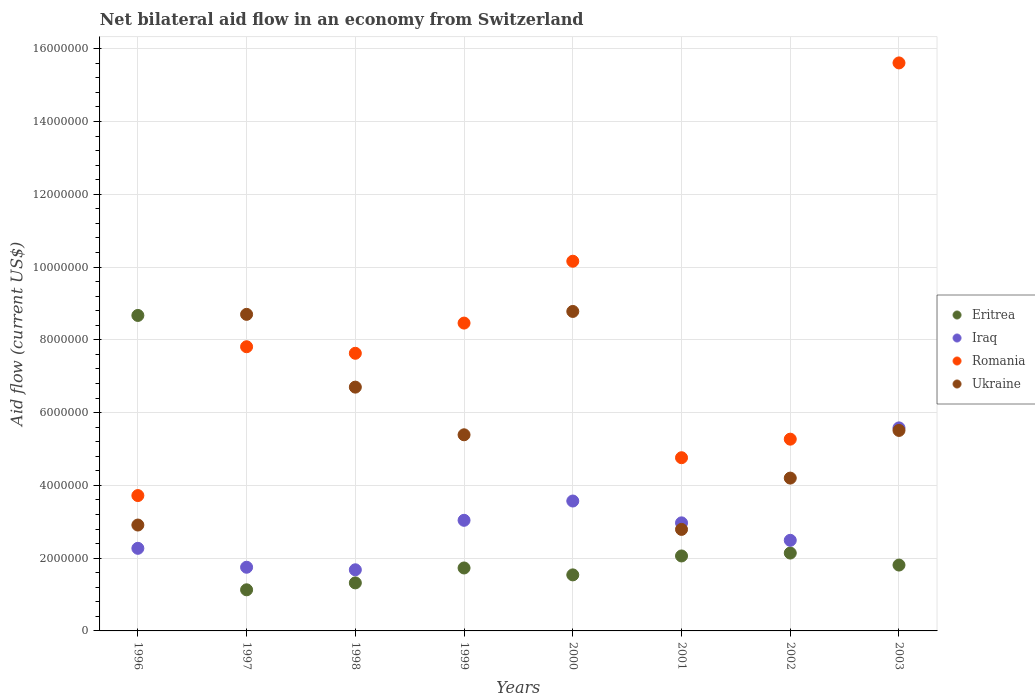How many different coloured dotlines are there?
Keep it short and to the point. 4. Is the number of dotlines equal to the number of legend labels?
Make the answer very short. Yes. What is the net bilateral aid flow in Ukraine in 1997?
Your answer should be very brief. 8.70e+06. Across all years, what is the maximum net bilateral aid flow in Eritrea?
Your answer should be very brief. 8.67e+06. Across all years, what is the minimum net bilateral aid flow in Ukraine?
Provide a succinct answer. 2.79e+06. In which year was the net bilateral aid flow in Ukraine maximum?
Make the answer very short. 2000. What is the total net bilateral aid flow in Romania in the graph?
Your answer should be compact. 6.34e+07. What is the difference between the net bilateral aid flow in Iraq in 1997 and that in 2003?
Your answer should be compact. -3.83e+06. What is the difference between the net bilateral aid flow in Romania in 2000 and the net bilateral aid flow in Ukraine in 1996?
Offer a very short reply. 7.25e+06. What is the average net bilateral aid flow in Iraq per year?
Make the answer very short. 2.92e+06. In the year 1998, what is the difference between the net bilateral aid flow in Ukraine and net bilateral aid flow in Romania?
Keep it short and to the point. -9.30e+05. In how many years, is the net bilateral aid flow in Iraq greater than 11600000 US$?
Ensure brevity in your answer.  0. What is the ratio of the net bilateral aid flow in Eritrea in 1996 to that in 2001?
Provide a short and direct response. 4.21. What is the difference between the highest and the second highest net bilateral aid flow in Ukraine?
Keep it short and to the point. 8.00e+04. What is the difference between the highest and the lowest net bilateral aid flow in Romania?
Your answer should be very brief. 1.19e+07. Is the sum of the net bilateral aid flow in Eritrea in 1997 and 2001 greater than the maximum net bilateral aid flow in Ukraine across all years?
Keep it short and to the point. No. Is it the case that in every year, the sum of the net bilateral aid flow in Iraq and net bilateral aid flow in Romania  is greater than the sum of net bilateral aid flow in Ukraine and net bilateral aid flow in Eritrea?
Offer a very short reply. No. Is it the case that in every year, the sum of the net bilateral aid flow in Iraq and net bilateral aid flow in Ukraine  is greater than the net bilateral aid flow in Romania?
Give a very brief answer. No. Is the net bilateral aid flow in Eritrea strictly greater than the net bilateral aid flow in Iraq over the years?
Provide a succinct answer. No. How many dotlines are there?
Offer a terse response. 4. Are the values on the major ticks of Y-axis written in scientific E-notation?
Ensure brevity in your answer.  No. Does the graph contain any zero values?
Offer a terse response. No. Where does the legend appear in the graph?
Your answer should be compact. Center right. How are the legend labels stacked?
Offer a terse response. Vertical. What is the title of the graph?
Your answer should be very brief. Net bilateral aid flow in an economy from Switzerland. What is the label or title of the Y-axis?
Your answer should be very brief. Aid flow (current US$). What is the Aid flow (current US$) in Eritrea in 1996?
Your answer should be very brief. 8.67e+06. What is the Aid flow (current US$) in Iraq in 1996?
Provide a short and direct response. 2.27e+06. What is the Aid flow (current US$) in Romania in 1996?
Your answer should be very brief. 3.72e+06. What is the Aid flow (current US$) of Ukraine in 1996?
Keep it short and to the point. 2.91e+06. What is the Aid flow (current US$) of Eritrea in 1997?
Offer a very short reply. 1.13e+06. What is the Aid flow (current US$) in Iraq in 1997?
Your answer should be compact. 1.75e+06. What is the Aid flow (current US$) of Romania in 1997?
Provide a short and direct response. 7.81e+06. What is the Aid flow (current US$) in Ukraine in 1997?
Provide a succinct answer. 8.70e+06. What is the Aid flow (current US$) in Eritrea in 1998?
Provide a short and direct response. 1.32e+06. What is the Aid flow (current US$) in Iraq in 1998?
Your answer should be very brief. 1.68e+06. What is the Aid flow (current US$) in Romania in 1998?
Your answer should be compact. 7.63e+06. What is the Aid flow (current US$) in Ukraine in 1998?
Offer a terse response. 6.70e+06. What is the Aid flow (current US$) in Eritrea in 1999?
Your response must be concise. 1.73e+06. What is the Aid flow (current US$) of Iraq in 1999?
Make the answer very short. 3.04e+06. What is the Aid flow (current US$) of Romania in 1999?
Your answer should be very brief. 8.46e+06. What is the Aid flow (current US$) in Ukraine in 1999?
Keep it short and to the point. 5.39e+06. What is the Aid flow (current US$) in Eritrea in 2000?
Make the answer very short. 1.54e+06. What is the Aid flow (current US$) of Iraq in 2000?
Your answer should be very brief. 3.57e+06. What is the Aid flow (current US$) of Romania in 2000?
Offer a terse response. 1.02e+07. What is the Aid flow (current US$) in Ukraine in 2000?
Ensure brevity in your answer.  8.78e+06. What is the Aid flow (current US$) of Eritrea in 2001?
Ensure brevity in your answer.  2.06e+06. What is the Aid flow (current US$) in Iraq in 2001?
Ensure brevity in your answer.  2.97e+06. What is the Aid flow (current US$) in Romania in 2001?
Provide a short and direct response. 4.76e+06. What is the Aid flow (current US$) of Ukraine in 2001?
Offer a terse response. 2.79e+06. What is the Aid flow (current US$) of Eritrea in 2002?
Ensure brevity in your answer.  2.14e+06. What is the Aid flow (current US$) in Iraq in 2002?
Ensure brevity in your answer.  2.49e+06. What is the Aid flow (current US$) of Romania in 2002?
Keep it short and to the point. 5.27e+06. What is the Aid flow (current US$) in Ukraine in 2002?
Keep it short and to the point. 4.20e+06. What is the Aid flow (current US$) of Eritrea in 2003?
Offer a very short reply. 1.81e+06. What is the Aid flow (current US$) in Iraq in 2003?
Provide a short and direct response. 5.58e+06. What is the Aid flow (current US$) in Romania in 2003?
Give a very brief answer. 1.56e+07. What is the Aid flow (current US$) in Ukraine in 2003?
Your answer should be compact. 5.51e+06. Across all years, what is the maximum Aid flow (current US$) in Eritrea?
Your answer should be very brief. 8.67e+06. Across all years, what is the maximum Aid flow (current US$) in Iraq?
Your answer should be compact. 5.58e+06. Across all years, what is the maximum Aid flow (current US$) in Romania?
Provide a short and direct response. 1.56e+07. Across all years, what is the maximum Aid flow (current US$) in Ukraine?
Ensure brevity in your answer.  8.78e+06. Across all years, what is the minimum Aid flow (current US$) of Eritrea?
Provide a succinct answer. 1.13e+06. Across all years, what is the minimum Aid flow (current US$) of Iraq?
Your answer should be compact. 1.68e+06. Across all years, what is the minimum Aid flow (current US$) of Romania?
Provide a short and direct response. 3.72e+06. Across all years, what is the minimum Aid flow (current US$) of Ukraine?
Make the answer very short. 2.79e+06. What is the total Aid flow (current US$) of Eritrea in the graph?
Give a very brief answer. 2.04e+07. What is the total Aid flow (current US$) of Iraq in the graph?
Your answer should be very brief. 2.34e+07. What is the total Aid flow (current US$) in Romania in the graph?
Your response must be concise. 6.34e+07. What is the total Aid flow (current US$) in Ukraine in the graph?
Give a very brief answer. 4.50e+07. What is the difference between the Aid flow (current US$) of Eritrea in 1996 and that in 1997?
Your answer should be very brief. 7.54e+06. What is the difference between the Aid flow (current US$) in Iraq in 1996 and that in 1997?
Your answer should be compact. 5.20e+05. What is the difference between the Aid flow (current US$) of Romania in 1996 and that in 1997?
Provide a succinct answer. -4.09e+06. What is the difference between the Aid flow (current US$) in Ukraine in 1996 and that in 1997?
Ensure brevity in your answer.  -5.79e+06. What is the difference between the Aid flow (current US$) of Eritrea in 1996 and that in 1998?
Provide a short and direct response. 7.35e+06. What is the difference between the Aid flow (current US$) of Iraq in 1996 and that in 1998?
Ensure brevity in your answer.  5.90e+05. What is the difference between the Aid flow (current US$) of Romania in 1996 and that in 1998?
Make the answer very short. -3.91e+06. What is the difference between the Aid flow (current US$) of Ukraine in 1996 and that in 1998?
Provide a short and direct response. -3.79e+06. What is the difference between the Aid flow (current US$) in Eritrea in 1996 and that in 1999?
Make the answer very short. 6.94e+06. What is the difference between the Aid flow (current US$) of Iraq in 1996 and that in 1999?
Your response must be concise. -7.70e+05. What is the difference between the Aid flow (current US$) of Romania in 1996 and that in 1999?
Your answer should be very brief. -4.74e+06. What is the difference between the Aid flow (current US$) in Ukraine in 1996 and that in 1999?
Offer a terse response. -2.48e+06. What is the difference between the Aid flow (current US$) of Eritrea in 1996 and that in 2000?
Your answer should be very brief. 7.13e+06. What is the difference between the Aid flow (current US$) in Iraq in 1996 and that in 2000?
Keep it short and to the point. -1.30e+06. What is the difference between the Aid flow (current US$) of Romania in 1996 and that in 2000?
Offer a very short reply. -6.44e+06. What is the difference between the Aid flow (current US$) of Ukraine in 1996 and that in 2000?
Offer a terse response. -5.87e+06. What is the difference between the Aid flow (current US$) of Eritrea in 1996 and that in 2001?
Your answer should be very brief. 6.61e+06. What is the difference between the Aid flow (current US$) in Iraq in 1996 and that in 2001?
Make the answer very short. -7.00e+05. What is the difference between the Aid flow (current US$) in Romania in 1996 and that in 2001?
Your response must be concise. -1.04e+06. What is the difference between the Aid flow (current US$) of Ukraine in 1996 and that in 2001?
Offer a very short reply. 1.20e+05. What is the difference between the Aid flow (current US$) of Eritrea in 1996 and that in 2002?
Make the answer very short. 6.53e+06. What is the difference between the Aid flow (current US$) in Iraq in 1996 and that in 2002?
Your response must be concise. -2.20e+05. What is the difference between the Aid flow (current US$) in Romania in 1996 and that in 2002?
Provide a short and direct response. -1.55e+06. What is the difference between the Aid flow (current US$) in Ukraine in 1996 and that in 2002?
Keep it short and to the point. -1.29e+06. What is the difference between the Aid flow (current US$) of Eritrea in 1996 and that in 2003?
Offer a terse response. 6.86e+06. What is the difference between the Aid flow (current US$) of Iraq in 1996 and that in 2003?
Provide a short and direct response. -3.31e+06. What is the difference between the Aid flow (current US$) of Romania in 1996 and that in 2003?
Your answer should be very brief. -1.19e+07. What is the difference between the Aid flow (current US$) in Ukraine in 1996 and that in 2003?
Give a very brief answer. -2.60e+06. What is the difference between the Aid flow (current US$) of Iraq in 1997 and that in 1998?
Your answer should be very brief. 7.00e+04. What is the difference between the Aid flow (current US$) of Eritrea in 1997 and that in 1999?
Ensure brevity in your answer.  -6.00e+05. What is the difference between the Aid flow (current US$) of Iraq in 1997 and that in 1999?
Offer a terse response. -1.29e+06. What is the difference between the Aid flow (current US$) of Romania in 1997 and that in 1999?
Provide a short and direct response. -6.50e+05. What is the difference between the Aid flow (current US$) in Ukraine in 1997 and that in 1999?
Keep it short and to the point. 3.31e+06. What is the difference between the Aid flow (current US$) in Eritrea in 1997 and that in 2000?
Ensure brevity in your answer.  -4.10e+05. What is the difference between the Aid flow (current US$) of Iraq in 1997 and that in 2000?
Offer a very short reply. -1.82e+06. What is the difference between the Aid flow (current US$) of Romania in 1997 and that in 2000?
Ensure brevity in your answer.  -2.35e+06. What is the difference between the Aid flow (current US$) in Ukraine in 1997 and that in 2000?
Make the answer very short. -8.00e+04. What is the difference between the Aid flow (current US$) in Eritrea in 1997 and that in 2001?
Keep it short and to the point. -9.30e+05. What is the difference between the Aid flow (current US$) in Iraq in 1997 and that in 2001?
Ensure brevity in your answer.  -1.22e+06. What is the difference between the Aid flow (current US$) in Romania in 1997 and that in 2001?
Ensure brevity in your answer.  3.05e+06. What is the difference between the Aid flow (current US$) of Ukraine in 1997 and that in 2001?
Offer a terse response. 5.91e+06. What is the difference between the Aid flow (current US$) of Eritrea in 1997 and that in 2002?
Provide a succinct answer. -1.01e+06. What is the difference between the Aid flow (current US$) of Iraq in 1997 and that in 2002?
Give a very brief answer. -7.40e+05. What is the difference between the Aid flow (current US$) of Romania in 1997 and that in 2002?
Keep it short and to the point. 2.54e+06. What is the difference between the Aid flow (current US$) of Ukraine in 1997 and that in 2002?
Ensure brevity in your answer.  4.50e+06. What is the difference between the Aid flow (current US$) of Eritrea in 1997 and that in 2003?
Your answer should be very brief. -6.80e+05. What is the difference between the Aid flow (current US$) in Iraq in 1997 and that in 2003?
Offer a terse response. -3.83e+06. What is the difference between the Aid flow (current US$) in Romania in 1997 and that in 2003?
Make the answer very short. -7.80e+06. What is the difference between the Aid flow (current US$) of Ukraine in 1997 and that in 2003?
Make the answer very short. 3.19e+06. What is the difference between the Aid flow (current US$) of Eritrea in 1998 and that in 1999?
Provide a short and direct response. -4.10e+05. What is the difference between the Aid flow (current US$) in Iraq in 1998 and that in 1999?
Keep it short and to the point. -1.36e+06. What is the difference between the Aid flow (current US$) of Romania in 1998 and that in 1999?
Make the answer very short. -8.30e+05. What is the difference between the Aid flow (current US$) of Ukraine in 1998 and that in 1999?
Offer a very short reply. 1.31e+06. What is the difference between the Aid flow (current US$) of Iraq in 1998 and that in 2000?
Your response must be concise. -1.89e+06. What is the difference between the Aid flow (current US$) of Romania in 1998 and that in 2000?
Keep it short and to the point. -2.53e+06. What is the difference between the Aid flow (current US$) in Ukraine in 1998 and that in 2000?
Offer a very short reply. -2.08e+06. What is the difference between the Aid flow (current US$) in Eritrea in 1998 and that in 2001?
Ensure brevity in your answer.  -7.40e+05. What is the difference between the Aid flow (current US$) of Iraq in 1998 and that in 2001?
Keep it short and to the point. -1.29e+06. What is the difference between the Aid flow (current US$) in Romania in 1998 and that in 2001?
Your answer should be compact. 2.87e+06. What is the difference between the Aid flow (current US$) of Ukraine in 1998 and that in 2001?
Provide a succinct answer. 3.91e+06. What is the difference between the Aid flow (current US$) in Eritrea in 1998 and that in 2002?
Offer a very short reply. -8.20e+05. What is the difference between the Aid flow (current US$) in Iraq in 1998 and that in 2002?
Your answer should be compact. -8.10e+05. What is the difference between the Aid flow (current US$) of Romania in 1998 and that in 2002?
Ensure brevity in your answer.  2.36e+06. What is the difference between the Aid flow (current US$) in Ukraine in 1998 and that in 2002?
Your response must be concise. 2.50e+06. What is the difference between the Aid flow (current US$) in Eritrea in 1998 and that in 2003?
Provide a succinct answer. -4.90e+05. What is the difference between the Aid flow (current US$) of Iraq in 1998 and that in 2003?
Your answer should be very brief. -3.90e+06. What is the difference between the Aid flow (current US$) in Romania in 1998 and that in 2003?
Ensure brevity in your answer.  -7.98e+06. What is the difference between the Aid flow (current US$) in Ukraine in 1998 and that in 2003?
Keep it short and to the point. 1.19e+06. What is the difference between the Aid flow (current US$) in Eritrea in 1999 and that in 2000?
Give a very brief answer. 1.90e+05. What is the difference between the Aid flow (current US$) in Iraq in 1999 and that in 2000?
Your response must be concise. -5.30e+05. What is the difference between the Aid flow (current US$) in Romania in 1999 and that in 2000?
Make the answer very short. -1.70e+06. What is the difference between the Aid flow (current US$) of Ukraine in 1999 and that in 2000?
Make the answer very short. -3.39e+06. What is the difference between the Aid flow (current US$) in Eritrea in 1999 and that in 2001?
Your answer should be very brief. -3.30e+05. What is the difference between the Aid flow (current US$) in Romania in 1999 and that in 2001?
Your answer should be compact. 3.70e+06. What is the difference between the Aid flow (current US$) of Ukraine in 1999 and that in 2001?
Provide a short and direct response. 2.60e+06. What is the difference between the Aid flow (current US$) in Eritrea in 1999 and that in 2002?
Offer a very short reply. -4.10e+05. What is the difference between the Aid flow (current US$) in Iraq in 1999 and that in 2002?
Offer a terse response. 5.50e+05. What is the difference between the Aid flow (current US$) of Romania in 1999 and that in 2002?
Offer a very short reply. 3.19e+06. What is the difference between the Aid flow (current US$) in Ukraine in 1999 and that in 2002?
Keep it short and to the point. 1.19e+06. What is the difference between the Aid flow (current US$) in Iraq in 1999 and that in 2003?
Offer a terse response. -2.54e+06. What is the difference between the Aid flow (current US$) of Romania in 1999 and that in 2003?
Provide a succinct answer. -7.15e+06. What is the difference between the Aid flow (current US$) in Eritrea in 2000 and that in 2001?
Provide a succinct answer. -5.20e+05. What is the difference between the Aid flow (current US$) of Romania in 2000 and that in 2001?
Offer a very short reply. 5.40e+06. What is the difference between the Aid flow (current US$) of Ukraine in 2000 and that in 2001?
Give a very brief answer. 5.99e+06. What is the difference between the Aid flow (current US$) of Eritrea in 2000 and that in 2002?
Provide a short and direct response. -6.00e+05. What is the difference between the Aid flow (current US$) in Iraq in 2000 and that in 2002?
Your answer should be compact. 1.08e+06. What is the difference between the Aid flow (current US$) in Romania in 2000 and that in 2002?
Keep it short and to the point. 4.89e+06. What is the difference between the Aid flow (current US$) of Ukraine in 2000 and that in 2002?
Ensure brevity in your answer.  4.58e+06. What is the difference between the Aid flow (current US$) in Iraq in 2000 and that in 2003?
Provide a short and direct response. -2.01e+06. What is the difference between the Aid flow (current US$) in Romania in 2000 and that in 2003?
Give a very brief answer. -5.45e+06. What is the difference between the Aid flow (current US$) in Ukraine in 2000 and that in 2003?
Offer a very short reply. 3.27e+06. What is the difference between the Aid flow (current US$) in Iraq in 2001 and that in 2002?
Your answer should be very brief. 4.80e+05. What is the difference between the Aid flow (current US$) of Romania in 2001 and that in 2002?
Offer a terse response. -5.10e+05. What is the difference between the Aid flow (current US$) of Ukraine in 2001 and that in 2002?
Offer a terse response. -1.41e+06. What is the difference between the Aid flow (current US$) in Iraq in 2001 and that in 2003?
Provide a short and direct response. -2.61e+06. What is the difference between the Aid flow (current US$) of Romania in 2001 and that in 2003?
Make the answer very short. -1.08e+07. What is the difference between the Aid flow (current US$) in Ukraine in 2001 and that in 2003?
Offer a terse response. -2.72e+06. What is the difference between the Aid flow (current US$) of Iraq in 2002 and that in 2003?
Provide a short and direct response. -3.09e+06. What is the difference between the Aid flow (current US$) in Romania in 2002 and that in 2003?
Your answer should be compact. -1.03e+07. What is the difference between the Aid flow (current US$) in Ukraine in 2002 and that in 2003?
Your answer should be compact. -1.31e+06. What is the difference between the Aid flow (current US$) in Eritrea in 1996 and the Aid flow (current US$) in Iraq in 1997?
Provide a short and direct response. 6.92e+06. What is the difference between the Aid flow (current US$) in Eritrea in 1996 and the Aid flow (current US$) in Romania in 1997?
Ensure brevity in your answer.  8.60e+05. What is the difference between the Aid flow (current US$) of Eritrea in 1996 and the Aid flow (current US$) of Ukraine in 1997?
Give a very brief answer. -3.00e+04. What is the difference between the Aid flow (current US$) in Iraq in 1996 and the Aid flow (current US$) in Romania in 1997?
Your answer should be compact. -5.54e+06. What is the difference between the Aid flow (current US$) of Iraq in 1996 and the Aid flow (current US$) of Ukraine in 1997?
Provide a short and direct response. -6.43e+06. What is the difference between the Aid flow (current US$) in Romania in 1996 and the Aid flow (current US$) in Ukraine in 1997?
Provide a short and direct response. -4.98e+06. What is the difference between the Aid flow (current US$) of Eritrea in 1996 and the Aid flow (current US$) of Iraq in 1998?
Offer a terse response. 6.99e+06. What is the difference between the Aid flow (current US$) in Eritrea in 1996 and the Aid flow (current US$) in Romania in 1998?
Your answer should be very brief. 1.04e+06. What is the difference between the Aid flow (current US$) in Eritrea in 1996 and the Aid flow (current US$) in Ukraine in 1998?
Offer a terse response. 1.97e+06. What is the difference between the Aid flow (current US$) in Iraq in 1996 and the Aid flow (current US$) in Romania in 1998?
Offer a very short reply. -5.36e+06. What is the difference between the Aid flow (current US$) in Iraq in 1996 and the Aid flow (current US$) in Ukraine in 1998?
Provide a succinct answer. -4.43e+06. What is the difference between the Aid flow (current US$) of Romania in 1996 and the Aid flow (current US$) of Ukraine in 1998?
Make the answer very short. -2.98e+06. What is the difference between the Aid flow (current US$) in Eritrea in 1996 and the Aid flow (current US$) in Iraq in 1999?
Make the answer very short. 5.63e+06. What is the difference between the Aid flow (current US$) in Eritrea in 1996 and the Aid flow (current US$) in Ukraine in 1999?
Offer a terse response. 3.28e+06. What is the difference between the Aid flow (current US$) in Iraq in 1996 and the Aid flow (current US$) in Romania in 1999?
Ensure brevity in your answer.  -6.19e+06. What is the difference between the Aid flow (current US$) in Iraq in 1996 and the Aid flow (current US$) in Ukraine in 1999?
Your answer should be compact. -3.12e+06. What is the difference between the Aid flow (current US$) of Romania in 1996 and the Aid flow (current US$) of Ukraine in 1999?
Give a very brief answer. -1.67e+06. What is the difference between the Aid flow (current US$) in Eritrea in 1996 and the Aid flow (current US$) in Iraq in 2000?
Your response must be concise. 5.10e+06. What is the difference between the Aid flow (current US$) in Eritrea in 1996 and the Aid flow (current US$) in Romania in 2000?
Your response must be concise. -1.49e+06. What is the difference between the Aid flow (current US$) of Iraq in 1996 and the Aid flow (current US$) of Romania in 2000?
Provide a succinct answer. -7.89e+06. What is the difference between the Aid flow (current US$) in Iraq in 1996 and the Aid flow (current US$) in Ukraine in 2000?
Your answer should be compact. -6.51e+06. What is the difference between the Aid flow (current US$) in Romania in 1996 and the Aid flow (current US$) in Ukraine in 2000?
Keep it short and to the point. -5.06e+06. What is the difference between the Aid flow (current US$) of Eritrea in 1996 and the Aid flow (current US$) of Iraq in 2001?
Provide a short and direct response. 5.70e+06. What is the difference between the Aid flow (current US$) of Eritrea in 1996 and the Aid flow (current US$) of Romania in 2001?
Ensure brevity in your answer.  3.91e+06. What is the difference between the Aid flow (current US$) of Eritrea in 1996 and the Aid flow (current US$) of Ukraine in 2001?
Your answer should be compact. 5.88e+06. What is the difference between the Aid flow (current US$) of Iraq in 1996 and the Aid flow (current US$) of Romania in 2001?
Ensure brevity in your answer.  -2.49e+06. What is the difference between the Aid flow (current US$) in Iraq in 1996 and the Aid flow (current US$) in Ukraine in 2001?
Your response must be concise. -5.20e+05. What is the difference between the Aid flow (current US$) in Romania in 1996 and the Aid flow (current US$) in Ukraine in 2001?
Provide a short and direct response. 9.30e+05. What is the difference between the Aid flow (current US$) of Eritrea in 1996 and the Aid flow (current US$) of Iraq in 2002?
Provide a succinct answer. 6.18e+06. What is the difference between the Aid flow (current US$) of Eritrea in 1996 and the Aid flow (current US$) of Romania in 2002?
Your answer should be compact. 3.40e+06. What is the difference between the Aid flow (current US$) of Eritrea in 1996 and the Aid flow (current US$) of Ukraine in 2002?
Provide a succinct answer. 4.47e+06. What is the difference between the Aid flow (current US$) of Iraq in 1996 and the Aid flow (current US$) of Romania in 2002?
Keep it short and to the point. -3.00e+06. What is the difference between the Aid flow (current US$) of Iraq in 1996 and the Aid flow (current US$) of Ukraine in 2002?
Provide a short and direct response. -1.93e+06. What is the difference between the Aid flow (current US$) of Romania in 1996 and the Aid flow (current US$) of Ukraine in 2002?
Make the answer very short. -4.80e+05. What is the difference between the Aid flow (current US$) of Eritrea in 1996 and the Aid flow (current US$) of Iraq in 2003?
Your answer should be very brief. 3.09e+06. What is the difference between the Aid flow (current US$) in Eritrea in 1996 and the Aid flow (current US$) in Romania in 2003?
Give a very brief answer. -6.94e+06. What is the difference between the Aid flow (current US$) of Eritrea in 1996 and the Aid flow (current US$) of Ukraine in 2003?
Provide a short and direct response. 3.16e+06. What is the difference between the Aid flow (current US$) of Iraq in 1996 and the Aid flow (current US$) of Romania in 2003?
Your response must be concise. -1.33e+07. What is the difference between the Aid flow (current US$) of Iraq in 1996 and the Aid flow (current US$) of Ukraine in 2003?
Give a very brief answer. -3.24e+06. What is the difference between the Aid flow (current US$) in Romania in 1996 and the Aid flow (current US$) in Ukraine in 2003?
Your answer should be compact. -1.79e+06. What is the difference between the Aid flow (current US$) of Eritrea in 1997 and the Aid flow (current US$) of Iraq in 1998?
Provide a short and direct response. -5.50e+05. What is the difference between the Aid flow (current US$) in Eritrea in 1997 and the Aid flow (current US$) in Romania in 1998?
Your answer should be compact. -6.50e+06. What is the difference between the Aid flow (current US$) of Eritrea in 1997 and the Aid flow (current US$) of Ukraine in 1998?
Offer a terse response. -5.57e+06. What is the difference between the Aid flow (current US$) of Iraq in 1997 and the Aid flow (current US$) of Romania in 1998?
Keep it short and to the point. -5.88e+06. What is the difference between the Aid flow (current US$) in Iraq in 1997 and the Aid flow (current US$) in Ukraine in 1998?
Ensure brevity in your answer.  -4.95e+06. What is the difference between the Aid flow (current US$) of Romania in 1997 and the Aid flow (current US$) of Ukraine in 1998?
Your response must be concise. 1.11e+06. What is the difference between the Aid flow (current US$) in Eritrea in 1997 and the Aid flow (current US$) in Iraq in 1999?
Offer a terse response. -1.91e+06. What is the difference between the Aid flow (current US$) in Eritrea in 1997 and the Aid flow (current US$) in Romania in 1999?
Give a very brief answer. -7.33e+06. What is the difference between the Aid flow (current US$) in Eritrea in 1997 and the Aid flow (current US$) in Ukraine in 1999?
Make the answer very short. -4.26e+06. What is the difference between the Aid flow (current US$) in Iraq in 1997 and the Aid flow (current US$) in Romania in 1999?
Make the answer very short. -6.71e+06. What is the difference between the Aid flow (current US$) of Iraq in 1997 and the Aid flow (current US$) of Ukraine in 1999?
Your answer should be compact. -3.64e+06. What is the difference between the Aid flow (current US$) in Romania in 1997 and the Aid flow (current US$) in Ukraine in 1999?
Offer a very short reply. 2.42e+06. What is the difference between the Aid flow (current US$) of Eritrea in 1997 and the Aid flow (current US$) of Iraq in 2000?
Provide a short and direct response. -2.44e+06. What is the difference between the Aid flow (current US$) in Eritrea in 1997 and the Aid flow (current US$) in Romania in 2000?
Your answer should be compact. -9.03e+06. What is the difference between the Aid flow (current US$) in Eritrea in 1997 and the Aid flow (current US$) in Ukraine in 2000?
Keep it short and to the point. -7.65e+06. What is the difference between the Aid flow (current US$) of Iraq in 1997 and the Aid flow (current US$) of Romania in 2000?
Your answer should be compact. -8.41e+06. What is the difference between the Aid flow (current US$) in Iraq in 1997 and the Aid flow (current US$) in Ukraine in 2000?
Make the answer very short. -7.03e+06. What is the difference between the Aid flow (current US$) of Romania in 1997 and the Aid flow (current US$) of Ukraine in 2000?
Offer a terse response. -9.70e+05. What is the difference between the Aid flow (current US$) of Eritrea in 1997 and the Aid flow (current US$) of Iraq in 2001?
Keep it short and to the point. -1.84e+06. What is the difference between the Aid flow (current US$) in Eritrea in 1997 and the Aid flow (current US$) in Romania in 2001?
Give a very brief answer. -3.63e+06. What is the difference between the Aid flow (current US$) of Eritrea in 1997 and the Aid flow (current US$) of Ukraine in 2001?
Your answer should be very brief. -1.66e+06. What is the difference between the Aid flow (current US$) in Iraq in 1997 and the Aid flow (current US$) in Romania in 2001?
Provide a succinct answer. -3.01e+06. What is the difference between the Aid flow (current US$) in Iraq in 1997 and the Aid flow (current US$) in Ukraine in 2001?
Offer a very short reply. -1.04e+06. What is the difference between the Aid flow (current US$) in Romania in 1997 and the Aid flow (current US$) in Ukraine in 2001?
Offer a terse response. 5.02e+06. What is the difference between the Aid flow (current US$) of Eritrea in 1997 and the Aid flow (current US$) of Iraq in 2002?
Make the answer very short. -1.36e+06. What is the difference between the Aid flow (current US$) in Eritrea in 1997 and the Aid flow (current US$) in Romania in 2002?
Your answer should be very brief. -4.14e+06. What is the difference between the Aid flow (current US$) in Eritrea in 1997 and the Aid flow (current US$) in Ukraine in 2002?
Your response must be concise. -3.07e+06. What is the difference between the Aid flow (current US$) in Iraq in 1997 and the Aid flow (current US$) in Romania in 2002?
Provide a short and direct response. -3.52e+06. What is the difference between the Aid flow (current US$) in Iraq in 1997 and the Aid flow (current US$) in Ukraine in 2002?
Your answer should be compact. -2.45e+06. What is the difference between the Aid flow (current US$) of Romania in 1997 and the Aid flow (current US$) of Ukraine in 2002?
Your response must be concise. 3.61e+06. What is the difference between the Aid flow (current US$) of Eritrea in 1997 and the Aid flow (current US$) of Iraq in 2003?
Your answer should be compact. -4.45e+06. What is the difference between the Aid flow (current US$) of Eritrea in 1997 and the Aid flow (current US$) of Romania in 2003?
Your answer should be very brief. -1.45e+07. What is the difference between the Aid flow (current US$) in Eritrea in 1997 and the Aid flow (current US$) in Ukraine in 2003?
Your response must be concise. -4.38e+06. What is the difference between the Aid flow (current US$) of Iraq in 1997 and the Aid flow (current US$) of Romania in 2003?
Provide a succinct answer. -1.39e+07. What is the difference between the Aid flow (current US$) in Iraq in 1997 and the Aid flow (current US$) in Ukraine in 2003?
Give a very brief answer. -3.76e+06. What is the difference between the Aid flow (current US$) of Romania in 1997 and the Aid flow (current US$) of Ukraine in 2003?
Offer a terse response. 2.30e+06. What is the difference between the Aid flow (current US$) in Eritrea in 1998 and the Aid flow (current US$) in Iraq in 1999?
Give a very brief answer. -1.72e+06. What is the difference between the Aid flow (current US$) in Eritrea in 1998 and the Aid flow (current US$) in Romania in 1999?
Offer a terse response. -7.14e+06. What is the difference between the Aid flow (current US$) of Eritrea in 1998 and the Aid flow (current US$) of Ukraine in 1999?
Ensure brevity in your answer.  -4.07e+06. What is the difference between the Aid flow (current US$) in Iraq in 1998 and the Aid flow (current US$) in Romania in 1999?
Your response must be concise. -6.78e+06. What is the difference between the Aid flow (current US$) of Iraq in 1998 and the Aid flow (current US$) of Ukraine in 1999?
Your answer should be very brief. -3.71e+06. What is the difference between the Aid flow (current US$) of Romania in 1998 and the Aid flow (current US$) of Ukraine in 1999?
Your answer should be compact. 2.24e+06. What is the difference between the Aid flow (current US$) in Eritrea in 1998 and the Aid flow (current US$) in Iraq in 2000?
Offer a terse response. -2.25e+06. What is the difference between the Aid flow (current US$) of Eritrea in 1998 and the Aid flow (current US$) of Romania in 2000?
Provide a short and direct response. -8.84e+06. What is the difference between the Aid flow (current US$) in Eritrea in 1998 and the Aid flow (current US$) in Ukraine in 2000?
Offer a terse response. -7.46e+06. What is the difference between the Aid flow (current US$) in Iraq in 1998 and the Aid flow (current US$) in Romania in 2000?
Keep it short and to the point. -8.48e+06. What is the difference between the Aid flow (current US$) of Iraq in 1998 and the Aid flow (current US$) of Ukraine in 2000?
Ensure brevity in your answer.  -7.10e+06. What is the difference between the Aid flow (current US$) of Romania in 1998 and the Aid flow (current US$) of Ukraine in 2000?
Provide a succinct answer. -1.15e+06. What is the difference between the Aid flow (current US$) of Eritrea in 1998 and the Aid flow (current US$) of Iraq in 2001?
Offer a very short reply. -1.65e+06. What is the difference between the Aid flow (current US$) of Eritrea in 1998 and the Aid flow (current US$) of Romania in 2001?
Your answer should be compact. -3.44e+06. What is the difference between the Aid flow (current US$) in Eritrea in 1998 and the Aid flow (current US$) in Ukraine in 2001?
Your response must be concise. -1.47e+06. What is the difference between the Aid flow (current US$) of Iraq in 1998 and the Aid flow (current US$) of Romania in 2001?
Your response must be concise. -3.08e+06. What is the difference between the Aid flow (current US$) in Iraq in 1998 and the Aid flow (current US$) in Ukraine in 2001?
Provide a succinct answer. -1.11e+06. What is the difference between the Aid flow (current US$) of Romania in 1998 and the Aid flow (current US$) of Ukraine in 2001?
Make the answer very short. 4.84e+06. What is the difference between the Aid flow (current US$) in Eritrea in 1998 and the Aid flow (current US$) in Iraq in 2002?
Keep it short and to the point. -1.17e+06. What is the difference between the Aid flow (current US$) in Eritrea in 1998 and the Aid flow (current US$) in Romania in 2002?
Provide a succinct answer. -3.95e+06. What is the difference between the Aid flow (current US$) in Eritrea in 1998 and the Aid flow (current US$) in Ukraine in 2002?
Offer a terse response. -2.88e+06. What is the difference between the Aid flow (current US$) in Iraq in 1998 and the Aid flow (current US$) in Romania in 2002?
Your response must be concise. -3.59e+06. What is the difference between the Aid flow (current US$) in Iraq in 1998 and the Aid flow (current US$) in Ukraine in 2002?
Provide a succinct answer. -2.52e+06. What is the difference between the Aid flow (current US$) in Romania in 1998 and the Aid flow (current US$) in Ukraine in 2002?
Give a very brief answer. 3.43e+06. What is the difference between the Aid flow (current US$) of Eritrea in 1998 and the Aid flow (current US$) of Iraq in 2003?
Make the answer very short. -4.26e+06. What is the difference between the Aid flow (current US$) in Eritrea in 1998 and the Aid flow (current US$) in Romania in 2003?
Offer a terse response. -1.43e+07. What is the difference between the Aid flow (current US$) in Eritrea in 1998 and the Aid flow (current US$) in Ukraine in 2003?
Offer a very short reply. -4.19e+06. What is the difference between the Aid flow (current US$) in Iraq in 1998 and the Aid flow (current US$) in Romania in 2003?
Your answer should be compact. -1.39e+07. What is the difference between the Aid flow (current US$) in Iraq in 1998 and the Aid flow (current US$) in Ukraine in 2003?
Make the answer very short. -3.83e+06. What is the difference between the Aid flow (current US$) of Romania in 1998 and the Aid flow (current US$) of Ukraine in 2003?
Your answer should be compact. 2.12e+06. What is the difference between the Aid flow (current US$) in Eritrea in 1999 and the Aid flow (current US$) in Iraq in 2000?
Make the answer very short. -1.84e+06. What is the difference between the Aid flow (current US$) of Eritrea in 1999 and the Aid flow (current US$) of Romania in 2000?
Your answer should be very brief. -8.43e+06. What is the difference between the Aid flow (current US$) in Eritrea in 1999 and the Aid flow (current US$) in Ukraine in 2000?
Your answer should be very brief. -7.05e+06. What is the difference between the Aid flow (current US$) in Iraq in 1999 and the Aid flow (current US$) in Romania in 2000?
Provide a succinct answer. -7.12e+06. What is the difference between the Aid flow (current US$) of Iraq in 1999 and the Aid flow (current US$) of Ukraine in 2000?
Provide a short and direct response. -5.74e+06. What is the difference between the Aid flow (current US$) of Romania in 1999 and the Aid flow (current US$) of Ukraine in 2000?
Offer a terse response. -3.20e+05. What is the difference between the Aid flow (current US$) in Eritrea in 1999 and the Aid flow (current US$) in Iraq in 2001?
Your answer should be compact. -1.24e+06. What is the difference between the Aid flow (current US$) in Eritrea in 1999 and the Aid flow (current US$) in Romania in 2001?
Ensure brevity in your answer.  -3.03e+06. What is the difference between the Aid flow (current US$) in Eritrea in 1999 and the Aid flow (current US$) in Ukraine in 2001?
Offer a terse response. -1.06e+06. What is the difference between the Aid flow (current US$) of Iraq in 1999 and the Aid flow (current US$) of Romania in 2001?
Offer a terse response. -1.72e+06. What is the difference between the Aid flow (current US$) of Romania in 1999 and the Aid flow (current US$) of Ukraine in 2001?
Offer a terse response. 5.67e+06. What is the difference between the Aid flow (current US$) in Eritrea in 1999 and the Aid flow (current US$) in Iraq in 2002?
Offer a terse response. -7.60e+05. What is the difference between the Aid flow (current US$) of Eritrea in 1999 and the Aid flow (current US$) of Romania in 2002?
Offer a terse response. -3.54e+06. What is the difference between the Aid flow (current US$) of Eritrea in 1999 and the Aid flow (current US$) of Ukraine in 2002?
Keep it short and to the point. -2.47e+06. What is the difference between the Aid flow (current US$) in Iraq in 1999 and the Aid flow (current US$) in Romania in 2002?
Make the answer very short. -2.23e+06. What is the difference between the Aid flow (current US$) in Iraq in 1999 and the Aid flow (current US$) in Ukraine in 2002?
Provide a short and direct response. -1.16e+06. What is the difference between the Aid flow (current US$) of Romania in 1999 and the Aid flow (current US$) of Ukraine in 2002?
Your answer should be very brief. 4.26e+06. What is the difference between the Aid flow (current US$) in Eritrea in 1999 and the Aid flow (current US$) in Iraq in 2003?
Give a very brief answer. -3.85e+06. What is the difference between the Aid flow (current US$) of Eritrea in 1999 and the Aid flow (current US$) of Romania in 2003?
Make the answer very short. -1.39e+07. What is the difference between the Aid flow (current US$) of Eritrea in 1999 and the Aid flow (current US$) of Ukraine in 2003?
Your answer should be compact. -3.78e+06. What is the difference between the Aid flow (current US$) of Iraq in 1999 and the Aid flow (current US$) of Romania in 2003?
Ensure brevity in your answer.  -1.26e+07. What is the difference between the Aid flow (current US$) of Iraq in 1999 and the Aid flow (current US$) of Ukraine in 2003?
Your answer should be very brief. -2.47e+06. What is the difference between the Aid flow (current US$) of Romania in 1999 and the Aid flow (current US$) of Ukraine in 2003?
Your answer should be very brief. 2.95e+06. What is the difference between the Aid flow (current US$) of Eritrea in 2000 and the Aid flow (current US$) of Iraq in 2001?
Your response must be concise. -1.43e+06. What is the difference between the Aid flow (current US$) of Eritrea in 2000 and the Aid flow (current US$) of Romania in 2001?
Ensure brevity in your answer.  -3.22e+06. What is the difference between the Aid flow (current US$) of Eritrea in 2000 and the Aid flow (current US$) of Ukraine in 2001?
Your answer should be very brief. -1.25e+06. What is the difference between the Aid flow (current US$) in Iraq in 2000 and the Aid flow (current US$) in Romania in 2001?
Your answer should be compact. -1.19e+06. What is the difference between the Aid flow (current US$) of Iraq in 2000 and the Aid flow (current US$) of Ukraine in 2001?
Ensure brevity in your answer.  7.80e+05. What is the difference between the Aid flow (current US$) of Romania in 2000 and the Aid flow (current US$) of Ukraine in 2001?
Offer a very short reply. 7.37e+06. What is the difference between the Aid flow (current US$) of Eritrea in 2000 and the Aid flow (current US$) of Iraq in 2002?
Your answer should be compact. -9.50e+05. What is the difference between the Aid flow (current US$) of Eritrea in 2000 and the Aid flow (current US$) of Romania in 2002?
Keep it short and to the point. -3.73e+06. What is the difference between the Aid flow (current US$) in Eritrea in 2000 and the Aid flow (current US$) in Ukraine in 2002?
Your answer should be compact. -2.66e+06. What is the difference between the Aid flow (current US$) of Iraq in 2000 and the Aid flow (current US$) of Romania in 2002?
Your response must be concise. -1.70e+06. What is the difference between the Aid flow (current US$) in Iraq in 2000 and the Aid flow (current US$) in Ukraine in 2002?
Your response must be concise. -6.30e+05. What is the difference between the Aid flow (current US$) in Romania in 2000 and the Aid flow (current US$) in Ukraine in 2002?
Make the answer very short. 5.96e+06. What is the difference between the Aid flow (current US$) of Eritrea in 2000 and the Aid flow (current US$) of Iraq in 2003?
Provide a short and direct response. -4.04e+06. What is the difference between the Aid flow (current US$) in Eritrea in 2000 and the Aid flow (current US$) in Romania in 2003?
Your answer should be compact. -1.41e+07. What is the difference between the Aid flow (current US$) of Eritrea in 2000 and the Aid flow (current US$) of Ukraine in 2003?
Your answer should be very brief. -3.97e+06. What is the difference between the Aid flow (current US$) of Iraq in 2000 and the Aid flow (current US$) of Romania in 2003?
Your answer should be very brief. -1.20e+07. What is the difference between the Aid flow (current US$) of Iraq in 2000 and the Aid flow (current US$) of Ukraine in 2003?
Offer a very short reply. -1.94e+06. What is the difference between the Aid flow (current US$) of Romania in 2000 and the Aid flow (current US$) of Ukraine in 2003?
Give a very brief answer. 4.65e+06. What is the difference between the Aid flow (current US$) of Eritrea in 2001 and the Aid flow (current US$) of Iraq in 2002?
Offer a very short reply. -4.30e+05. What is the difference between the Aid flow (current US$) in Eritrea in 2001 and the Aid flow (current US$) in Romania in 2002?
Offer a very short reply. -3.21e+06. What is the difference between the Aid flow (current US$) of Eritrea in 2001 and the Aid flow (current US$) of Ukraine in 2002?
Keep it short and to the point. -2.14e+06. What is the difference between the Aid flow (current US$) of Iraq in 2001 and the Aid flow (current US$) of Romania in 2002?
Offer a very short reply. -2.30e+06. What is the difference between the Aid flow (current US$) of Iraq in 2001 and the Aid flow (current US$) of Ukraine in 2002?
Provide a short and direct response. -1.23e+06. What is the difference between the Aid flow (current US$) in Romania in 2001 and the Aid flow (current US$) in Ukraine in 2002?
Give a very brief answer. 5.60e+05. What is the difference between the Aid flow (current US$) of Eritrea in 2001 and the Aid flow (current US$) of Iraq in 2003?
Keep it short and to the point. -3.52e+06. What is the difference between the Aid flow (current US$) in Eritrea in 2001 and the Aid flow (current US$) in Romania in 2003?
Keep it short and to the point. -1.36e+07. What is the difference between the Aid flow (current US$) in Eritrea in 2001 and the Aid flow (current US$) in Ukraine in 2003?
Provide a short and direct response. -3.45e+06. What is the difference between the Aid flow (current US$) in Iraq in 2001 and the Aid flow (current US$) in Romania in 2003?
Provide a succinct answer. -1.26e+07. What is the difference between the Aid flow (current US$) of Iraq in 2001 and the Aid flow (current US$) of Ukraine in 2003?
Offer a terse response. -2.54e+06. What is the difference between the Aid flow (current US$) of Romania in 2001 and the Aid flow (current US$) of Ukraine in 2003?
Give a very brief answer. -7.50e+05. What is the difference between the Aid flow (current US$) of Eritrea in 2002 and the Aid flow (current US$) of Iraq in 2003?
Ensure brevity in your answer.  -3.44e+06. What is the difference between the Aid flow (current US$) in Eritrea in 2002 and the Aid flow (current US$) in Romania in 2003?
Your response must be concise. -1.35e+07. What is the difference between the Aid flow (current US$) in Eritrea in 2002 and the Aid flow (current US$) in Ukraine in 2003?
Your answer should be compact. -3.37e+06. What is the difference between the Aid flow (current US$) of Iraq in 2002 and the Aid flow (current US$) of Romania in 2003?
Give a very brief answer. -1.31e+07. What is the difference between the Aid flow (current US$) in Iraq in 2002 and the Aid flow (current US$) in Ukraine in 2003?
Your answer should be compact. -3.02e+06. What is the average Aid flow (current US$) in Eritrea per year?
Provide a short and direct response. 2.55e+06. What is the average Aid flow (current US$) in Iraq per year?
Make the answer very short. 2.92e+06. What is the average Aid flow (current US$) in Romania per year?
Your answer should be very brief. 7.93e+06. What is the average Aid flow (current US$) in Ukraine per year?
Your response must be concise. 5.62e+06. In the year 1996, what is the difference between the Aid flow (current US$) in Eritrea and Aid flow (current US$) in Iraq?
Offer a terse response. 6.40e+06. In the year 1996, what is the difference between the Aid flow (current US$) of Eritrea and Aid flow (current US$) of Romania?
Offer a terse response. 4.95e+06. In the year 1996, what is the difference between the Aid flow (current US$) of Eritrea and Aid flow (current US$) of Ukraine?
Your answer should be compact. 5.76e+06. In the year 1996, what is the difference between the Aid flow (current US$) of Iraq and Aid flow (current US$) of Romania?
Your response must be concise. -1.45e+06. In the year 1996, what is the difference between the Aid flow (current US$) of Iraq and Aid flow (current US$) of Ukraine?
Offer a very short reply. -6.40e+05. In the year 1996, what is the difference between the Aid flow (current US$) in Romania and Aid flow (current US$) in Ukraine?
Provide a short and direct response. 8.10e+05. In the year 1997, what is the difference between the Aid flow (current US$) of Eritrea and Aid flow (current US$) of Iraq?
Make the answer very short. -6.20e+05. In the year 1997, what is the difference between the Aid flow (current US$) of Eritrea and Aid flow (current US$) of Romania?
Keep it short and to the point. -6.68e+06. In the year 1997, what is the difference between the Aid flow (current US$) of Eritrea and Aid flow (current US$) of Ukraine?
Your answer should be very brief. -7.57e+06. In the year 1997, what is the difference between the Aid flow (current US$) of Iraq and Aid flow (current US$) of Romania?
Keep it short and to the point. -6.06e+06. In the year 1997, what is the difference between the Aid flow (current US$) in Iraq and Aid flow (current US$) in Ukraine?
Give a very brief answer. -6.95e+06. In the year 1997, what is the difference between the Aid flow (current US$) of Romania and Aid flow (current US$) of Ukraine?
Make the answer very short. -8.90e+05. In the year 1998, what is the difference between the Aid flow (current US$) in Eritrea and Aid flow (current US$) in Iraq?
Your answer should be very brief. -3.60e+05. In the year 1998, what is the difference between the Aid flow (current US$) of Eritrea and Aid flow (current US$) of Romania?
Make the answer very short. -6.31e+06. In the year 1998, what is the difference between the Aid flow (current US$) of Eritrea and Aid flow (current US$) of Ukraine?
Keep it short and to the point. -5.38e+06. In the year 1998, what is the difference between the Aid flow (current US$) of Iraq and Aid flow (current US$) of Romania?
Provide a short and direct response. -5.95e+06. In the year 1998, what is the difference between the Aid flow (current US$) in Iraq and Aid flow (current US$) in Ukraine?
Ensure brevity in your answer.  -5.02e+06. In the year 1998, what is the difference between the Aid flow (current US$) in Romania and Aid flow (current US$) in Ukraine?
Give a very brief answer. 9.30e+05. In the year 1999, what is the difference between the Aid flow (current US$) of Eritrea and Aid flow (current US$) of Iraq?
Your answer should be compact. -1.31e+06. In the year 1999, what is the difference between the Aid flow (current US$) in Eritrea and Aid flow (current US$) in Romania?
Your answer should be compact. -6.73e+06. In the year 1999, what is the difference between the Aid flow (current US$) in Eritrea and Aid flow (current US$) in Ukraine?
Provide a succinct answer. -3.66e+06. In the year 1999, what is the difference between the Aid flow (current US$) in Iraq and Aid flow (current US$) in Romania?
Offer a terse response. -5.42e+06. In the year 1999, what is the difference between the Aid flow (current US$) in Iraq and Aid flow (current US$) in Ukraine?
Offer a terse response. -2.35e+06. In the year 1999, what is the difference between the Aid flow (current US$) in Romania and Aid flow (current US$) in Ukraine?
Your answer should be very brief. 3.07e+06. In the year 2000, what is the difference between the Aid flow (current US$) of Eritrea and Aid flow (current US$) of Iraq?
Provide a succinct answer. -2.03e+06. In the year 2000, what is the difference between the Aid flow (current US$) of Eritrea and Aid flow (current US$) of Romania?
Your answer should be very brief. -8.62e+06. In the year 2000, what is the difference between the Aid flow (current US$) in Eritrea and Aid flow (current US$) in Ukraine?
Provide a short and direct response. -7.24e+06. In the year 2000, what is the difference between the Aid flow (current US$) of Iraq and Aid flow (current US$) of Romania?
Your answer should be compact. -6.59e+06. In the year 2000, what is the difference between the Aid flow (current US$) of Iraq and Aid flow (current US$) of Ukraine?
Provide a succinct answer. -5.21e+06. In the year 2000, what is the difference between the Aid flow (current US$) of Romania and Aid flow (current US$) of Ukraine?
Your answer should be very brief. 1.38e+06. In the year 2001, what is the difference between the Aid flow (current US$) in Eritrea and Aid flow (current US$) in Iraq?
Provide a short and direct response. -9.10e+05. In the year 2001, what is the difference between the Aid flow (current US$) in Eritrea and Aid flow (current US$) in Romania?
Keep it short and to the point. -2.70e+06. In the year 2001, what is the difference between the Aid flow (current US$) in Eritrea and Aid flow (current US$) in Ukraine?
Give a very brief answer. -7.30e+05. In the year 2001, what is the difference between the Aid flow (current US$) of Iraq and Aid flow (current US$) of Romania?
Offer a very short reply. -1.79e+06. In the year 2001, what is the difference between the Aid flow (current US$) in Iraq and Aid flow (current US$) in Ukraine?
Keep it short and to the point. 1.80e+05. In the year 2001, what is the difference between the Aid flow (current US$) of Romania and Aid flow (current US$) of Ukraine?
Give a very brief answer. 1.97e+06. In the year 2002, what is the difference between the Aid flow (current US$) in Eritrea and Aid flow (current US$) in Iraq?
Offer a very short reply. -3.50e+05. In the year 2002, what is the difference between the Aid flow (current US$) in Eritrea and Aid flow (current US$) in Romania?
Offer a terse response. -3.13e+06. In the year 2002, what is the difference between the Aid flow (current US$) in Eritrea and Aid flow (current US$) in Ukraine?
Your response must be concise. -2.06e+06. In the year 2002, what is the difference between the Aid flow (current US$) in Iraq and Aid flow (current US$) in Romania?
Offer a terse response. -2.78e+06. In the year 2002, what is the difference between the Aid flow (current US$) of Iraq and Aid flow (current US$) of Ukraine?
Offer a very short reply. -1.71e+06. In the year 2002, what is the difference between the Aid flow (current US$) of Romania and Aid flow (current US$) of Ukraine?
Your answer should be very brief. 1.07e+06. In the year 2003, what is the difference between the Aid flow (current US$) in Eritrea and Aid flow (current US$) in Iraq?
Make the answer very short. -3.77e+06. In the year 2003, what is the difference between the Aid flow (current US$) in Eritrea and Aid flow (current US$) in Romania?
Provide a succinct answer. -1.38e+07. In the year 2003, what is the difference between the Aid flow (current US$) of Eritrea and Aid flow (current US$) of Ukraine?
Your answer should be compact. -3.70e+06. In the year 2003, what is the difference between the Aid flow (current US$) of Iraq and Aid flow (current US$) of Romania?
Provide a short and direct response. -1.00e+07. In the year 2003, what is the difference between the Aid flow (current US$) in Iraq and Aid flow (current US$) in Ukraine?
Offer a very short reply. 7.00e+04. In the year 2003, what is the difference between the Aid flow (current US$) of Romania and Aid flow (current US$) of Ukraine?
Your response must be concise. 1.01e+07. What is the ratio of the Aid flow (current US$) in Eritrea in 1996 to that in 1997?
Keep it short and to the point. 7.67. What is the ratio of the Aid flow (current US$) in Iraq in 1996 to that in 1997?
Make the answer very short. 1.3. What is the ratio of the Aid flow (current US$) of Romania in 1996 to that in 1997?
Make the answer very short. 0.48. What is the ratio of the Aid flow (current US$) in Ukraine in 1996 to that in 1997?
Your answer should be compact. 0.33. What is the ratio of the Aid flow (current US$) in Eritrea in 1996 to that in 1998?
Give a very brief answer. 6.57. What is the ratio of the Aid flow (current US$) in Iraq in 1996 to that in 1998?
Your answer should be very brief. 1.35. What is the ratio of the Aid flow (current US$) in Romania in 1996 to that in 1998?
Keep it short and to the point. 0.49. What is the ratio of the Aid flow (current US$) of Ukraine in 1996 to that in 1998?
Provide a succinct answer. 0.43. What is the ratio of the Aid flow (current US$) of Eritrea in 1996 to that in 1999?
Give a very brief answer. 5.01. What is the ratio of the Aid flow (current US$) in Iraq in 1996 to that in 1999?
Your response must be concise. 0.75. What is the ratio of the Aid flow (current US$) in Romania in 1996 to that in 1999?
Ensure brevity in your answer.  0.44. What is the ratio of the Aid flow (current US$) of Ukraine in 1996 to that in 1999?
Your response must be concise. 0.54. What is the ratio of the Aid flow (current US$) in Eritrea in 1996 to that in 2000?
Provide a short and direct response. 5.63. What is the ratio of the Aid flow (current US$) in Iraq in 1996 to that in 2000?
Your answer should be very brief. 0.64. What is the ratio of the Aid flow (current US$) in Romania in 1996 to that in 2000?
Give a very brief answer. 0.37. What is the ratio of the Aid flow (current US$) of Ukraine in 1996 to that in 2000?
Provide a succinct answer. 0.33. What is the ratio of the Aid flow (current US$) in Eritrea in 1996 to that in 2001?
Ensure brevity in your answer.  4.21. What is the ratio of the Aid flow (current US$) of Iraq in 1996 to that in 2001?
Your answer should be very brief. 0.76. What is the ratio of the Aid flow (current US$) in Romania in 1996 to that in 2001?
Provide a short and direct response. 0.78. What is the ratio of the Aid flow (current US$) in Ukraine in 1996 to that in 2001?
Provide a short and direct response. 1.04. What is the ratio of the Aid flow (current US$) in Eritrea in 1996 to that in 2002?
Give a very brief answer. 4.05. What is the ratio of the Aid flow (current US$) in Iraq in 1996 to that in 2002?
Keep it short and to the point. 0.91. What is the ratio of the Aid flow (current US$) in Romania in 1996 to that in 2002?
Give a very brief answer. 0.71. What is the ratio of the Aid flow (current US$) in Ukraine in 1996 to that in 2002?
Give a very brief answer. 0.69. What is the ratio of the Aid flow (current US$) in Eritrea in 1996 to that in 2003?
Offer a very short reply. 4.79. What is the ratio of the Aid flow (current US$) in Iraq in 1996 to that in 2003?
Provide a short and direct response. 0.41. What is the ratio of the Aid flow (current US$) of Romania in 1996 to that in 2003?
Ensure brevity in your answer.  0.24. What is the ratio of the Aid flow (current US$) in Ukraine in 1996 to that in 2003?
Provide a short and direct response. 0.53. What is the ratio of the Aid flow (current US$) of Eritrea in 1997 to that in 1998?
Offer a terse response. 0.86. What is the ratio of the Aid flow (current US$) in Iraq in 1997 to that in 1998?
Offer a terse response. 1.04. What is the ratio of the Aid flow (current US$) in Romania in 1997 to that in 1998?
Make the answer very short. 1.02. What is the ratio of the Aid flow (current US$) in Ukraine in 1997 to that in 1998?
Provide a short and direct response. 1.3. What is the ratio of the Aid flow (current US$) in Eritrea in 1997 to that in 1999?
Provide a short and direct response. 0.65. What is the ratio of the Aid flow (current US$) in Iraq in 1997 to that in 1999?
Keep it short and to the point. 0.58. What is the ratio of the Aid flow (current US$) of Romania in 1997 to that in 1999?
Your response must be concise. 0.92. What is the ratio of the Aid flow (current US$) of Ukraine in 1997 to that in 1999?
Your answer should be very brief. 1.61. What is the ratio of the Aid flow (current US$) of Eritrea in 1997 to that in 2000?
Ensure brevity in your answer.  0.73. What is the ratio of the Aid flow (current US$) in Iraq in 1997 to that in 2000?
Provide a succinct answer. 0.49. What is the ratio of the Aid flow (current US$) in Romania in 1997 to that in 2000?
Provide a succinct answer. 0.77. What is the ratio of the Aid flow (current US$) of Ukraine in 1997 to that in 2000?
Make the answer very short. 0.99. What is the ratio of the Aid flow (current US$) of Eritrea in 1997 to that in 2001?
Your answer should be compact. 0.55. What is the ratio of the Aid flow (current US$) in Iraq in 1997 to that in 2001?
Your response must be concise. 0.59. What is the ratio of the Aid flow (current US$) in Romania in 1997 to that in 2001?
Your answer should be compact. 1.64. What is the ratio of the Aid flow (current US$) in Ukraine in 1997 to that in 2001?
Make the answer very short. 3.12. What is the ratio of the Aid flow (current US$) of Eritrea in 1997 to that in 2002?
Offer a terse response. 0.53. What is the ratio of the Aid flow (current US$) of Iraq in 1997 to that in 2002?
Ensure brevity in your answer.  0.7. What is the ratio of the Aid flow (current US$) in Romania in 1997 to that in 2002?
Your answer should be compact. 1.48. What is the ratio of the Aid flow (current US$) in Ukraine in 1997 to that in 2002?
Provide a succinct answer. 2.07. What is the ratio of the Aid flow (current US$) of Eritrea in 1997 to that in 2003?
Make the answer very short. 0.62. What is the ratio of the Aid flow (current US$) of Iraq in 1997 to that in 2003?
Your answer should be compact. 0.31. What is the ratio of the Aid flow (current US$) in Romania in 1997 to that in 2003?
Your answer should be very brief. 0.5. What is the ratio of the Aid flow (current US$) in Ukraine in 1997 to that in 2003?
Provide a short and direct response. 1.58. What is the ratio of the Aid flow (current US$) of Eritrea in 1998 to that in 1999?
Give a very brief answer. 0.76. What is the ratio of the Aid flow (current US$) in Iraq in 1998 to that in 1999?
Ensure brevity in your answer.  0.55. What is the ratio of the Aid flow (current US$) in Romania in 1998 to that in 1999?
Ensure brevity in your answer.  0.9. What is the ratio of the Aid flow (current US$) of Ukraine in 1998 to that in 1999?
Keep it short and to the point. 1.24. What is the ratio of the Aid flow (current US$) of Iraq in 1998 to that in 2000?
Offer a terse response. 0.47. What is the ratio of the Aid flow (current US$) in Romania in 1998 to that in 2000?
Keep it short and to the point. 0.75. What is the ratio of the Aid flow (current US$) of Ukraine in 1998 to that in 2000?
Your answer should be very brief. 0.76. What is the ratio of the Aid flow (current US$) in Eritrea in 1998 to that in 2001?
Your response must be concise. 0.64. What is the ratio of the Aid flow (current US$) of Iraq in 1998 to that in 2001?
Make the answer very short. 0.57. What is the ratio of the Aid flow (current US$) in Romania in 1998 to that in 2001?
Provide a succinct answer. 1.6. What is the ratio of the Aid flow (current US$) in Ukraine in 1998 to that in 2001?
Your answer should be very brief. 2.4. What is the ratio of the Aid flow (current US$) of Eritrea in 1998 to that in 2002?
Your answer should be compact. 0.62. What is the ratio of the Aid flow (current US$) in Iraq in 1998 to that in 2002?
Ensure brevity in your answer.  0.67. What is the ratio of the Aid flow (current US$) of Romania in 1998 to that in 2002?
Your answer should be very brief. 1.45. What is the ratio of the Aid flow (current US$) of Ukraine in 1998 to that in 2002?
Your answer should be compact. 1.6. What is the ratio of the Aid flow (current US$) of Eritrea in 1998 to that in 2003?
Your answer should be very brief. 0.73. What is the ratio of the Aid flow (current US$) in Iraq in 1998 to that in 2003?
Your answer should be compact. 0.3. What is the ratio of the Aid flow (current US$) in Romania in 1998 to that in 2003?
Your response must be concise. 0.49. What is the ratio of the Aid flow (current US$) in Ukraine in 1998 to that in 2003?
Make the answer very short. 1.22. What is the ratio of the Aid flow (current US$) of Eritrea in 1999 to that in 2000?
Provide a succinct answer. 1.12. What is the ratio of the Aid flow (current US$) of Iraq in 1999 to that in 2000?
Keep it short and to the point. 0.85. What is the ratio of the Aid flow (current US$) in Romania in 1999 to that in 2000?
Provide a succinct answer. 0.83. What is the ratio of the Aid flow (current US$) in Ukraine in 1999 to that in 2000?
Offer a very short reply. 0.61. What is the ratio of the Aid flow (current US$) of Eritrea in 1999 to that in 2001?
Your answer should be very brief. 0.84. What is the ratio of the Aid flow (current US$) of Iraq in 1999 to that in 2001?
Keep it short and to the point. 1.02. What is the ratio of the Aid flow (current US$) of Romania in 1999 to that in 2001?
Provide a succinct answer. 1.78. What is the ratio of the Aid flow (current US$) of Ukraine in 1999 to that in 2001?
Keep it short and to the point. 1.93. What is the ratio of the Aid flow (current US$) in Eritrea in 1999 to that in 2002?
Your answer should be compact. 0.81. What is the ratio of the Aid flow (current US$) in Iraq in 1999 to that in 2002?
Offer a terse response. 1.22. What is the ratio of the Aid flow (current US$) in Romania in 1999 to that in 2002?
Keep it short and to the point. 1.61. What is the ratio of the Aid flow (current US$) in Ukraine in 1999 to that in 2002?
Provide a succinct answer. 1.28. What is the ratio of the Aid flow (current US$) of Eritrea in 1999 to that in 2003?
Ensure brevity in your answer.  0.96. What is the ratio of the Aid flow (current US$) of Iraq in 1999 to that in 2003?
Provide a succinct answer. 0.54. What is the ratio of the Aid flow (current US$) of Romania in 1999 to that in 2003?
Your response must be concise. 0.54. What is the ratio of the Aid flow (current US$) of Ukraine in 1999 to that in 2003?
Keep it short and to the point. 0.98. What is the ratio of the Aid flow (current US$) in Eritrea in 2000 to that in 2001?
Offer a terse response. 0.75. What is the ratio of the Aid flow (current US$) in Iraq in 2000 to that in 2001?
Offer a very short reply. 1.2. What is the ratio of the Aid flow (current US$) in Romania in 2000 to that in 2001?
Provide a short and direct response. 2.13. What is the ratio of the Aid flow (current US$) in Ukraine in 2000 to that in 2001?
Your answer should be compact. 3.15. What is the ratio of the Aid flow (current US$) of Eritrea in 2000 to that in 2002?
Your answer should be very brief. 0.72. What is the ratio of the Aid flow (current US$) of Iraq in 2000 to that in 2002?
Give a very brief answer. 1.43. What is the ratio of the Aid flow (current US$) in Romania in 2000 to that in 2002?
Your answer should be compact. 1.93. What is the ratio of the Aid flow (current US$) in Ukraine in 2000 to that in 2002?
Your response must be concise. 2.09. What is the ratio of the Aid flow (current US$) in Eritrea in 2000 to that in 2003?
Make the answer very short. 0.85. What is the ratio of the Aid flow (current US$) of Iraq in 2000 to that in 2003?
Make the answer very short. 0.64. What is the ratio of the Aid flow (current US$) of Romania in 2000 to that in 2003?
Your response must be concise. 0.65. What is the ratio of the Aid flow (current US$) of Ukraine in 2000 to that in 2003?
Provide a short and direct response. 1.59. What is the ratio of the Aid flow (current US$) of Eritrea in 2001 to that in 2002?
Offer a terse response. 0.96. What is the ratio of the Aid flow (current US$) in Iraq in 2001 to that in 2002?
Your answer should be very brief. 1.19. What is the ratio of the Aid flow (current US$) of Romania in 2001 to that in 2002?
Provide a succinct answer. 0.9. What is the ratio of the Aid flow (current US$) in Ukraine in 2001 to that in 2002?
Provide a short and direct response. 0.66. What is the ratio of the Aid flow (current US$) in Eritrea in 2001 to that in 2003?
Keep it short and to the point. 1.14. What is the ratio of the Aid flow (current US$) of Iraq in 2001 to that in 2003?
Provide a succinct answer. 0.53. What is the ratio of the Aid flow (current US$) in Romania in 2001 to that in 2003?
Your answer should be very brief. 0.3. What is the ratio of the Aid flow (current US$) of Ukraine in 2001 to that in 2003?
Offer a very short reply. 0.51. What is the ratio of the Aid flow (current US$) in Eritrea in 2002 to that in 2003?
Provide a succinct answer. 1.18. What is the ratio of the Aid flow (current US$) of Iraq in 2002 to that in 2003?
Ensure brevity in your answer.  0.45. What is the ratio of the Aid flow (current US$) of Romania in 2002 to that in 2003?
Provide a short and direct response. 0.34. What is the ratio of the Aid flow (current US$) in Ukraine in 2002 to that in 2003?
Keep it short and to the point. 0.76. What is the difference between the highest and the second highest Aid flow (current US$) in Eritrea?
Offer a very short reply. 6.53e+06. What is the difference between the highest and the second highest Aid flow (current US$) of Iraq?
Make the answer very short. 2.01e+06. What is the difference between the highest and the second highest Aid flow (current US$) in Romania?
Your answer should be compact. 5.45e+06. What is the difference between the highest and the lowest Aid flow (current US$) in Eritrea?
Ensure brevity in your answer.  7.54e+06. What is the difference between the highest and the lowest Aid flow (current US$) in Iraq?
Your response must be concise. 3.90e+06. What is the difference between the highest and the lowest Aid flow (current US$) in Romania?
Provide a short and direct response. 1.19e+07. What is the difference between the highest and the lowest Aid flow (current US$) of Ukraine?
Make the answer very short. 5.99e+06. 